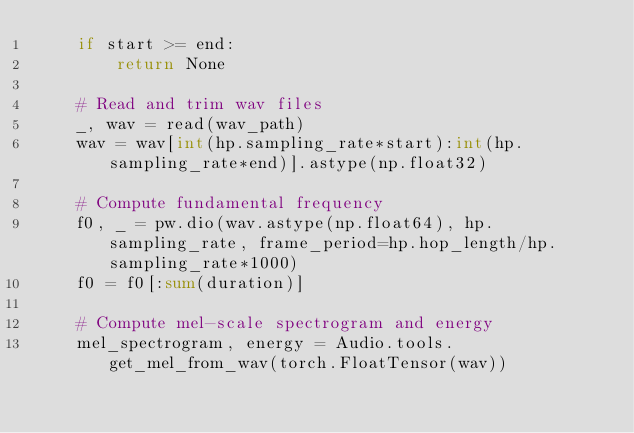<code> <loc_0><loc_0><loc_500><loc_500><_Python_>    if start >= end:
        return None

    # Read and trim wav files
    _, wav = read(wav_path)
    wav = wav[int(hp.sampling_rate*start):int(hp.sampling_rate*end)].astype(np.float32)

    # Compute fundamental frequency
    f0, _ = pw.dio(wav.astype(np.float64), hp.sampling_rate, frame_period=hp.hop_length/hp.sampling_rate*1000)
    f0 = f0[:sum(duration)]

    # Compute mel-scale spectrogram and energy
    mel_spectrogram, energy = Audio.tools.get_mel_from_wav(torch.FloatTensor(wav))</code> 